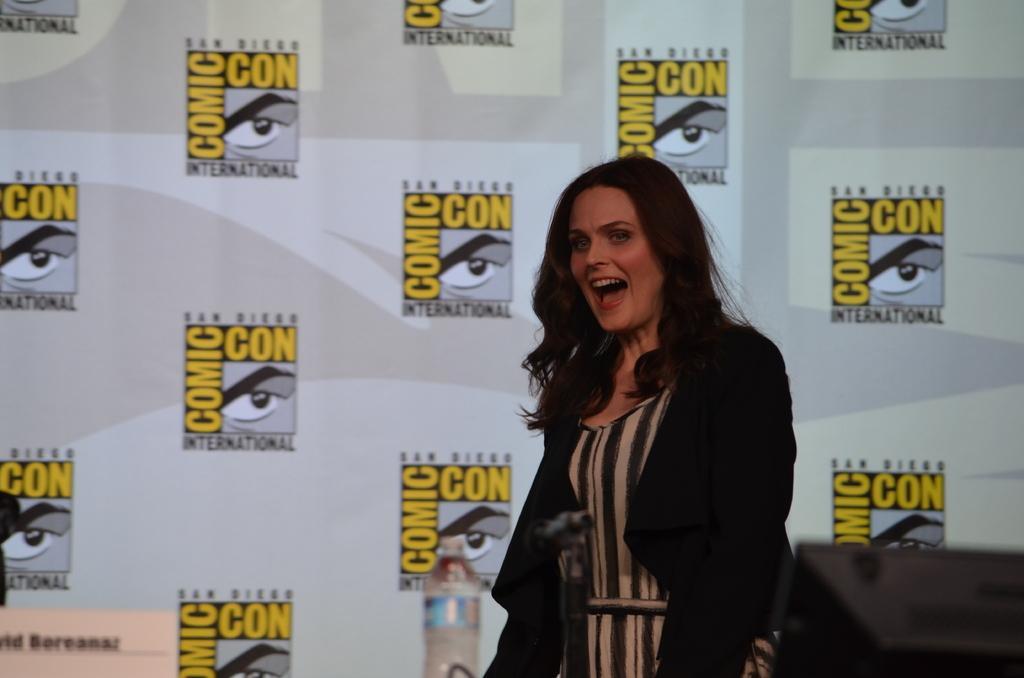Can you describe this image briefly? In this image we can see a woman. At the bottom there is a mic with mic stand. Also there is a bottle. In the background there is a wall with logos and something is written. 